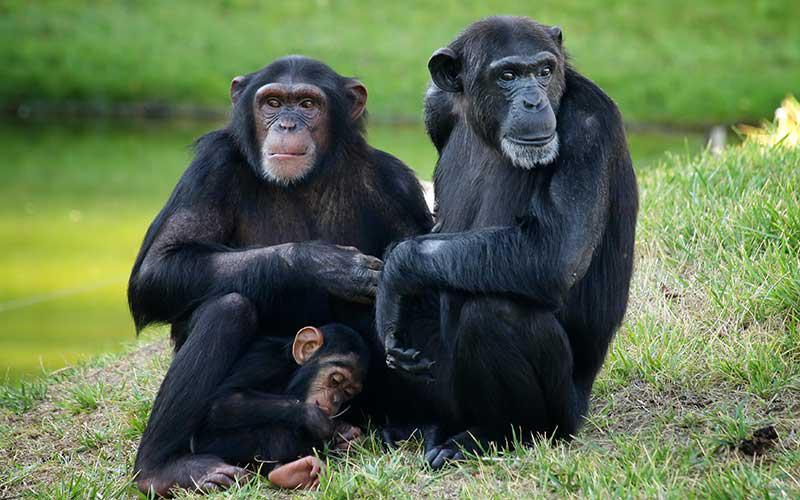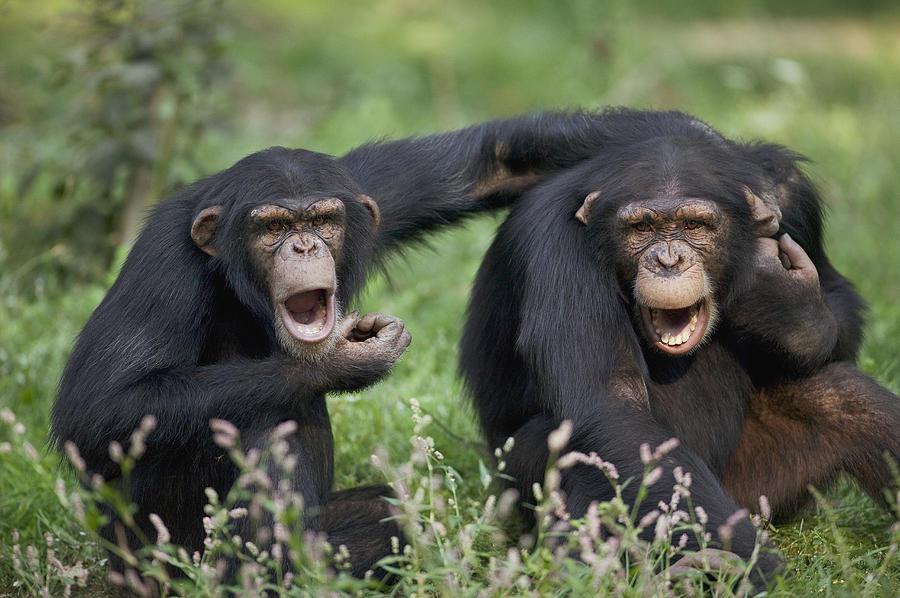The first image is the image on the left, the second image is the image on the right. Assess this claim about the two images: "At least one of the primates is on its hind legs.". Correct or not? Answer yes or no. No. The first image is the image on the left, the second image is the image on the right. Examine the images to the left and right. Is the description "The left image shows a group of three apes, with a fourth ape in the background." accurate? Answer yes or no. No. 